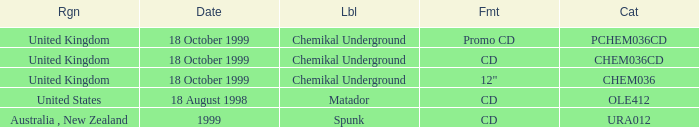What date is associated with the Spunk label? 1999.0. 